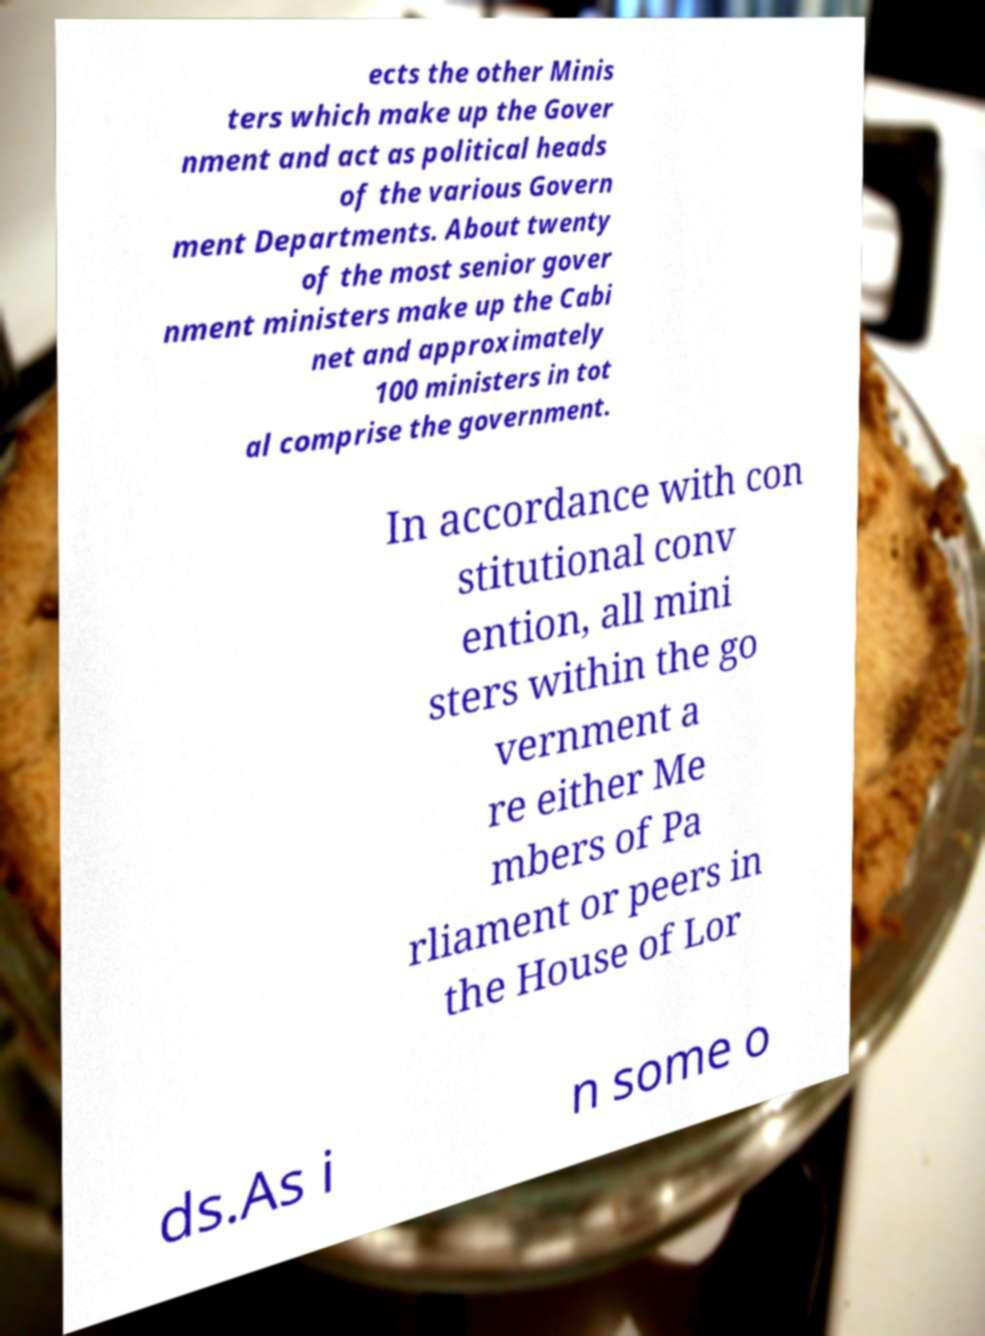Please identify and transcribe the text found in this image. ects the other Minis ters which make up the Gover nment and act as political heads of the various Govern ment Departments. About twenty of the most senior gover nment ministers make up the Cabi net and approximately 100 ministers in tot al comprise the government. In accordance with con stitutional conv ention, all mini sters within the go vernment a re either Me mbers of Pa rliament or peers in the House of Lor ds.As i n some o 